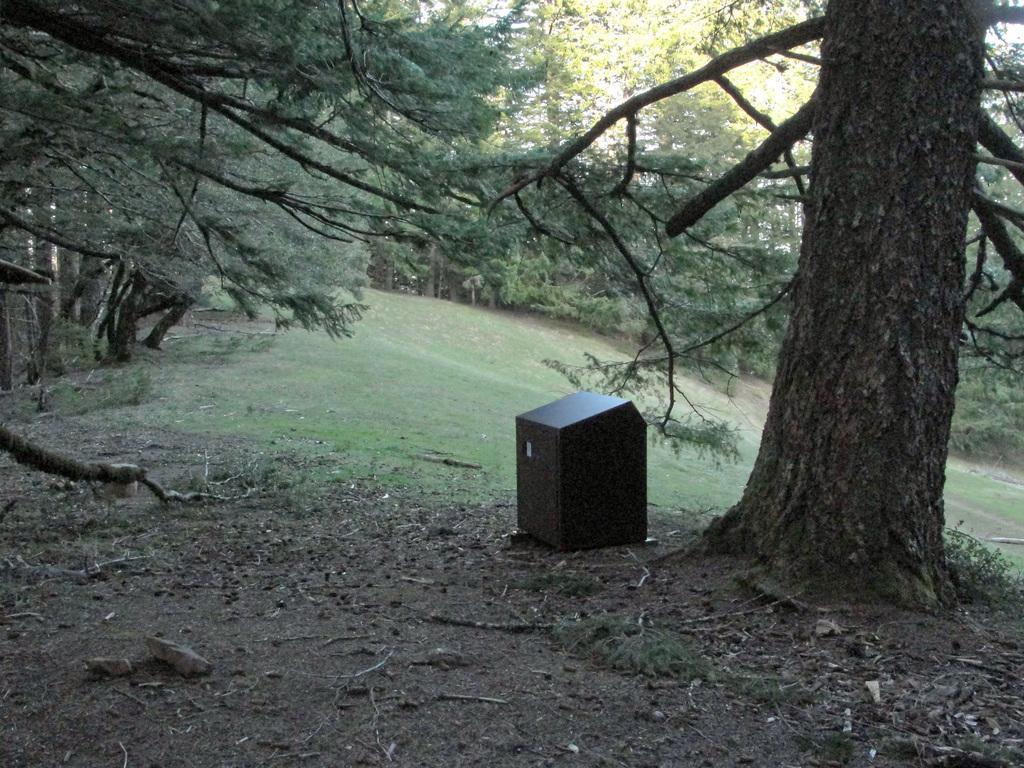Please provide a concise description of this image. In this picture I can observe some trees. There is a box on the ground, beside the tree. I can observe stones on the left side. 